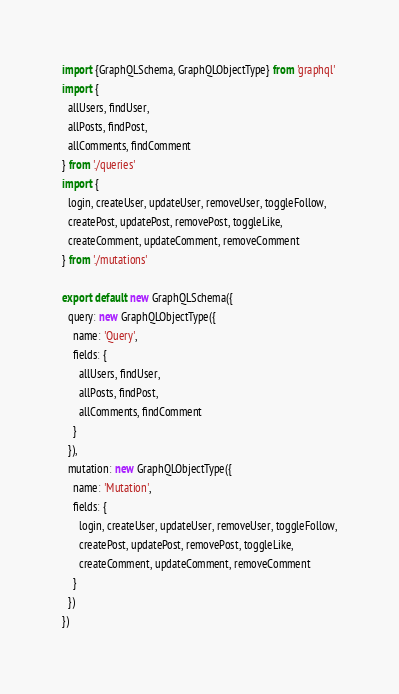<code> <loc_0><loc_0><loc_500><loc_500><_JavaScript_>import {GraphQLSchema, GraphQLObjectType} from 'graphql'
import {
  allUsers, findUser,
  allPosts, findPost,
  allComments, findComment
} from './queries'
import {
  login, createUser, updateUser, removeUser, toggleFollow,
  createPost, updatePost, removePost, toggleLike,
  createComment, updateComment, removeComment
} from './mutations'

export default new GraphQLSchema({
  query: new GraphQLObjectType({
    name: 'Query',
    fields: {
      allUsers, findUser,
      allPosts, findPost,
      allComments, findComment
    }
  }),
  mutation: new GraphQLObjectType({
    name: 'Mutation',
    fields: {
      login, createUser, updateUser, removeUser, toggleFollow,
      createPost, updatePost, removePost, toggleLike,
      createComment, updateComment, removeComment
    }
  })
})</code> 